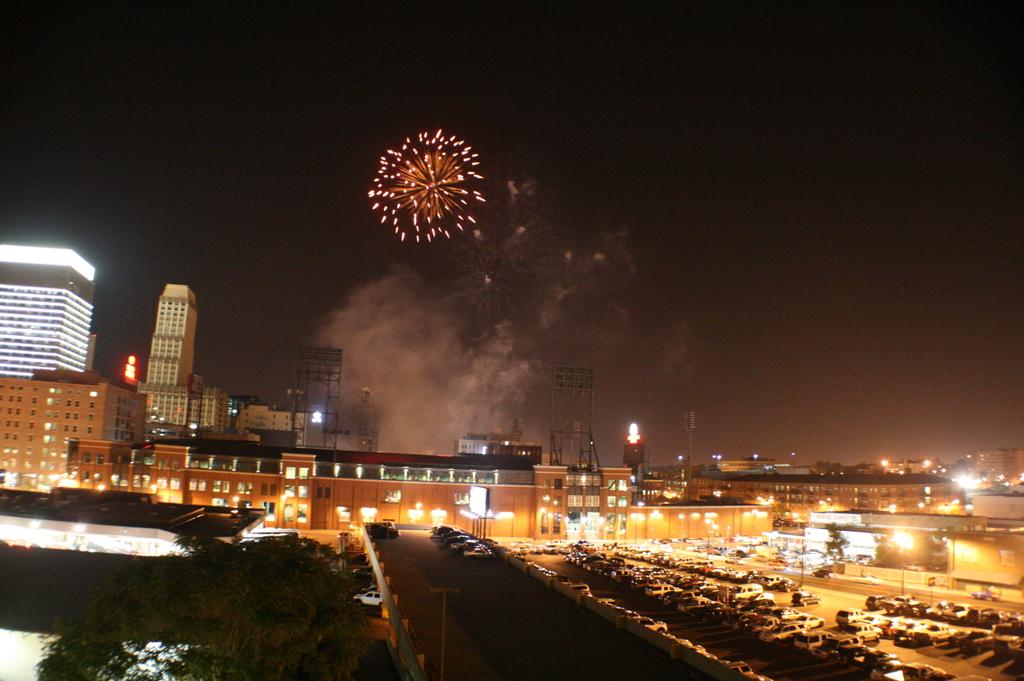What can be seen on the road in the image? There are cars on the road in the image. What is located on the left side of the image? There is a tree on the left side of the image. What is visible in the background of the image? There are buildings in the background of the image. What is the source of the smoke visible in the image? The source of the smoke is not specified in the image, but it could be from car exhaust or a nearby fire. What is the sparkle in the sky in the image? The sparkle in the sky could be a star, a planet, or a reflection of sunlight. Where are the chickens located in the image? There are no chickens present in the image. What type of bag is hanging from the tree on the left side of the image? There is no bag hanging from the tree on the left side of the image. 